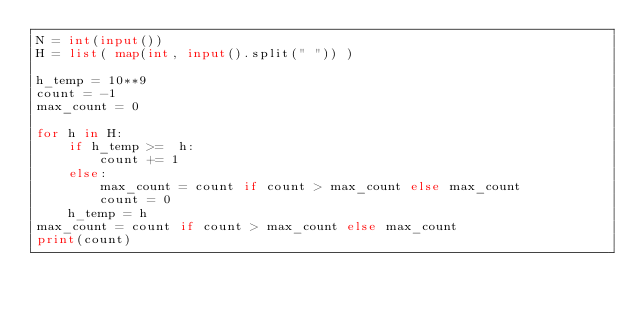<code> <loc_0><loc_0><loc_500><loc_500><_Python_>N = int(input())
H = list( map(int, input().split(" ")) )

h_temp = 10**9
count = -1
max_count = 0

for h in H:
    if h_temp >=  h:
        count += 1
    else:
        max_count = count if count > max_count else max_count
        count = 0
    h_temp = h
max_count = count if count > max_count else max_count
print(count)</code> 